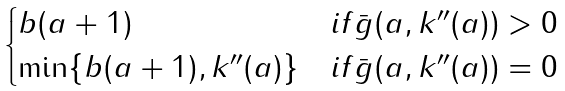<formula> <loc_0><loc_0><loc_500><loc_500>\begin{cases} b ( a + 1 ) & i f \bar { g } ( a , k ^ { \prime \prime } ( a ) ) > 0 \\ \min \{ b ( a + 1 ) , k ^ { \prime \prime } ( a ) \} & i f \bar { g } ( a , k ^ { \prime \prime } ( a ) ) = 0 \end{cases}</formula> 